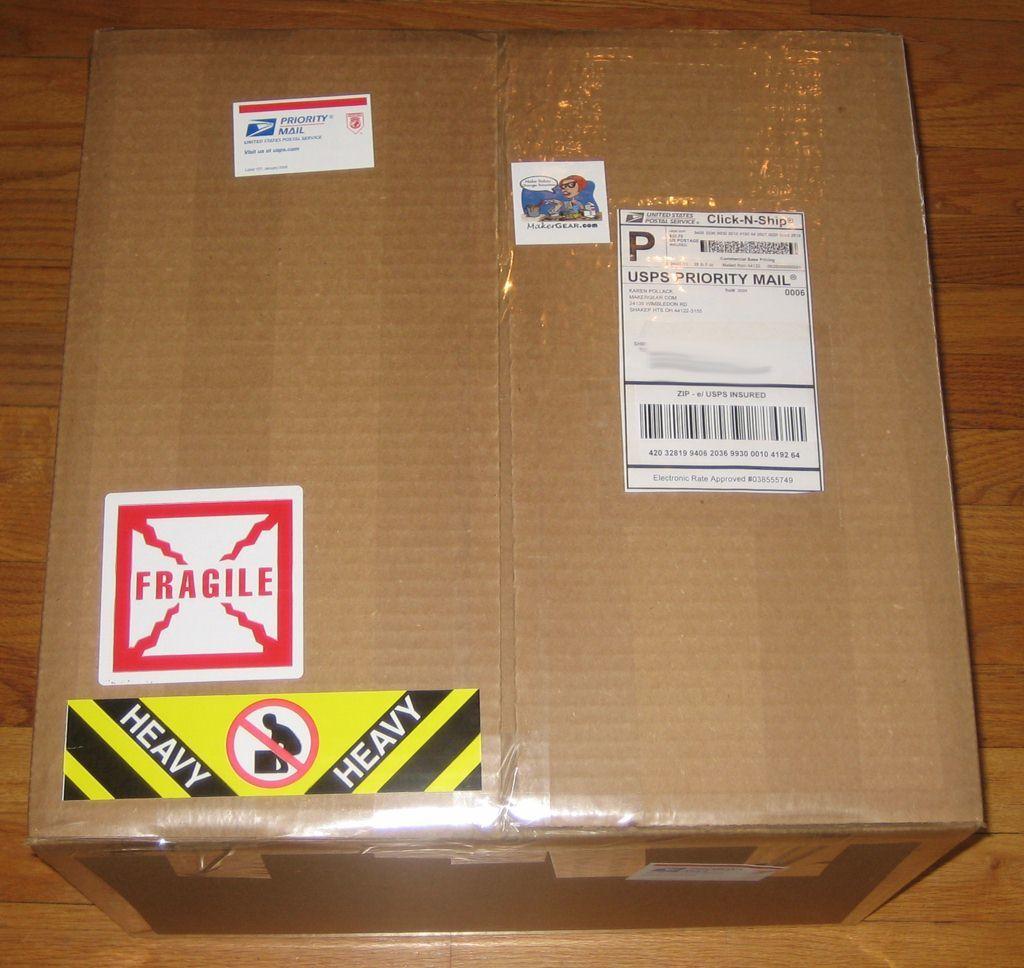Is this fragile?
Give a very brief answer. Yes. 